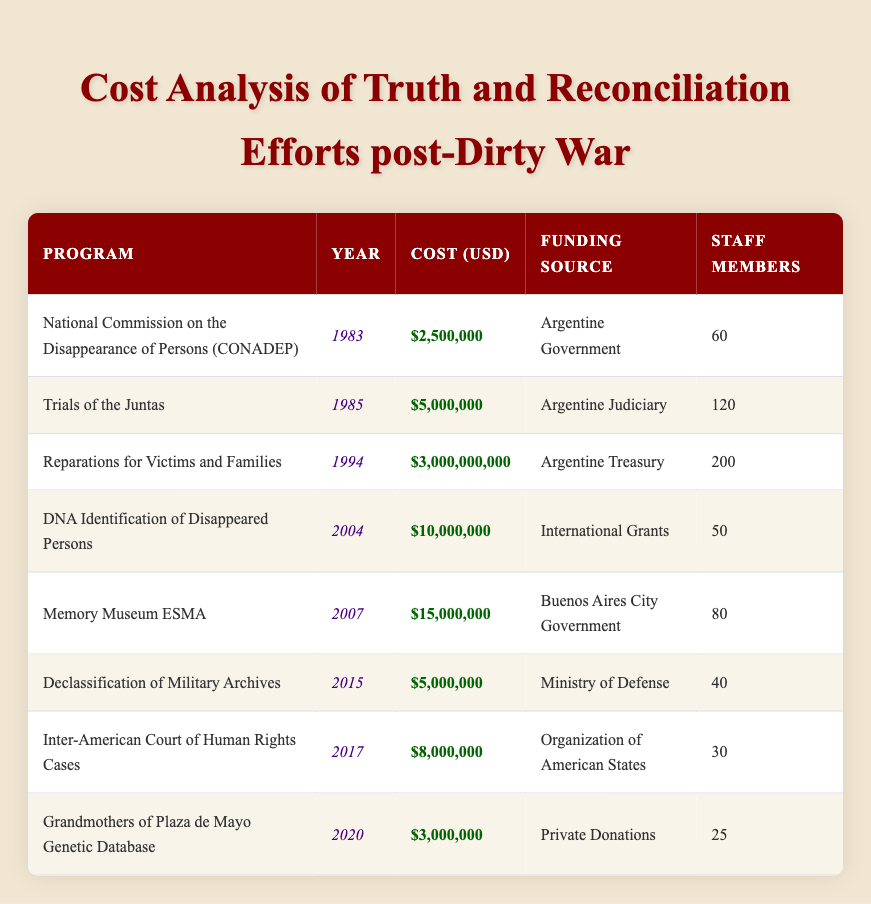What was the total cost of the Reparations for Victims and Families program? The table states that the cost of the Reparations for Victims and Families program is 3,000,000,000 USD. Therefore, the total cost is 3,000,000,000 USD.
Answer: 3,000,000,000 USD Which program had the highest staff involvement? By looking at the 'Staff Members' column, the Reparations for Victims and Families program has 200 staff members, which is the highest compared to the other programs listed.
Answer: Reparations for Victims and Families What is the average cost of all the truth and reconciliation efforts listed? First, sum the costs: 2,500,000 + 5,000,000 + 3,000,000,000 + 10,000,000 + 15,000,000 + 5,000,000 + 8,000,000 + 3,000,000 = 3,048,500,000. There are 8 programs, so the average is 3,048,500,000 / 8 = 381,062,500.
Answer: 381,062,500 USD Did the National Commission on the Disappearance of Persons receive funding from international sources? The funding source for the National Commission on the Disappearance of Persons was the Argentine Government, which means it did not receive funding from international sources.
Answer: No What was the total cost of programs funded by the Argentine Treasury? Only the Reparations for Victims and Families program was funded by the Argentine Treasury, costing 3,000,000,000 USD. Therefore, the total cost is also 3,000,000,000 USD.
Answer: 3,000,000,000 USD How many staff members were involved in programs between 2000 and 2015? The programs from 2000 to 2015 are DNA Identification of Disappeared Persons (50 staff), Memory Museum ESMA (80 staff), Declassification of Military Archives (40 staff), and Inter-American Court of Human Rights Cases (30 staff). Adding them gives 50 + 80 + 40 + 30 = 200 staff members.
Answer: 200 Which program was the most recent, and what was its cost? The most recent program listed is the Grandmothers of Plaza de Mayo Genetic Database in 2020 with a cost of 3,000,000 USD.
Answer: Grandmothers of Plaza de Mayo Genetic Database; 3,000,000 USD Did any program in the table have a cost below 10 million USD? The National Commission on the Disappearance of Persons (2,500,000 USD), the Trials of the Juntas (5,000,000 USD), and the Declassification of Military Archives (5,000,000 USD) all had costs below 10 million USD.
Answer: Yes 